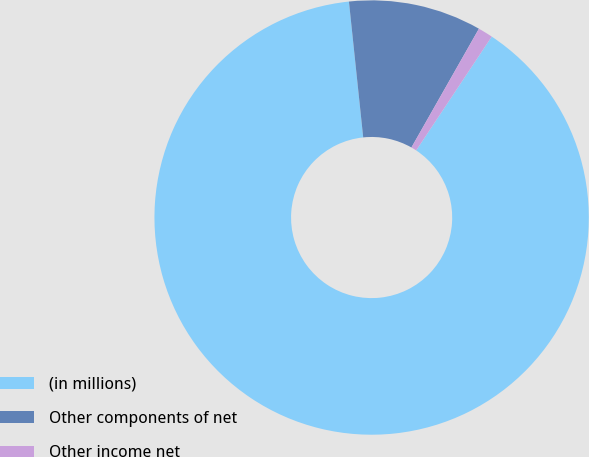Convert chart to OTSL. <chart><loc_0><loc_0><loc_500><loc_500><pie_chart><fcel>(in millions)<fcel>Other components of net<fcel>Other income net<nl><fcel>89.0%<fcel>9.89%<fcel>1.1%<nl></chart> 